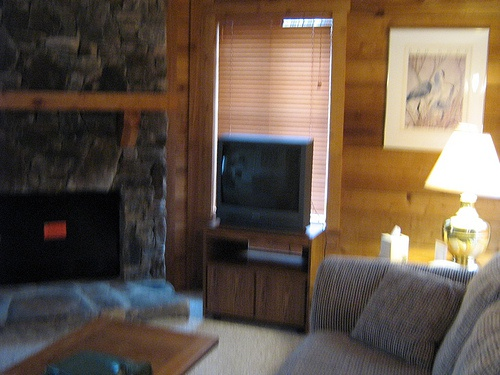Describe the objects in this image and their specific colors. I can see couch in black and gray tones, tv in black and gray tones, and dining table in black, maroon, and gray tones in this image. 